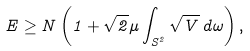<formula> <loc_0><loc_0><loc_500><loc_500>E \geq N \left ( 1 + \sqrt { 2 } \mu \int _ { S ^ { 2 } } \sqrt { V } \, d \omega \right ) ,</formula> 